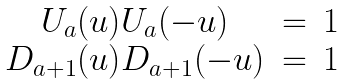<formula> <loc_0><loc_0><loc_500><loc_500>\begin{array} { c c c } U _ { a } ( u ) U _ { a } ( - u ) & = & 1 \\ D _ { a + 1 } ( u ) D _ { a + 1 } ( - u ) & = & 1 \end{array}</formula> 